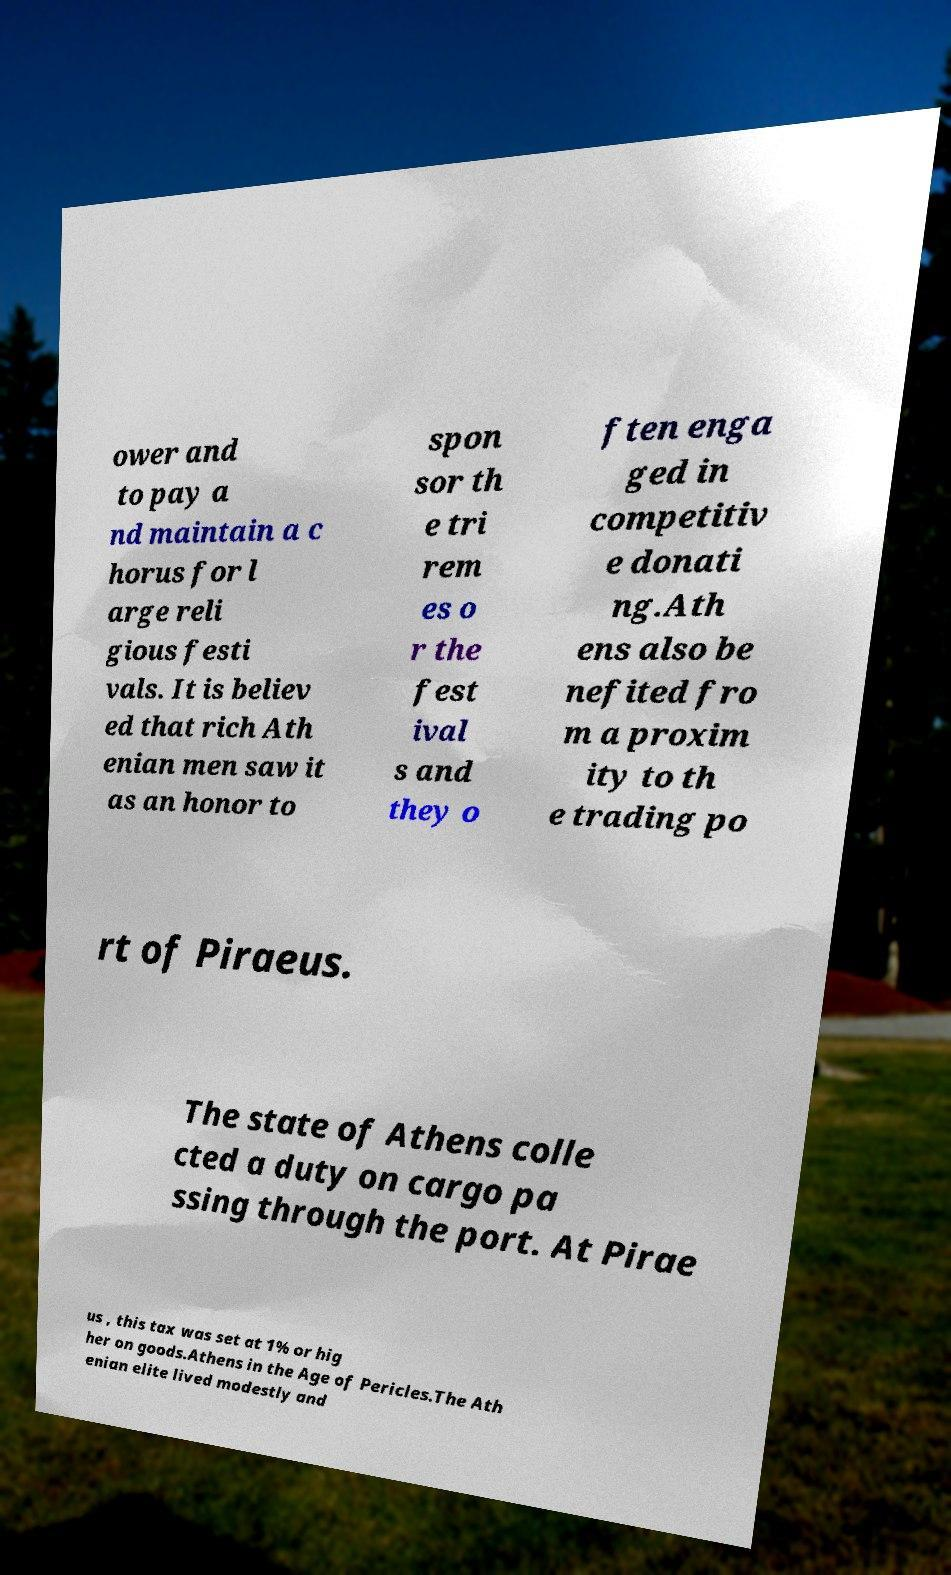Please read and relay the text visible in this image. What does it say? ower and to pay a nd maintain a c horus for l arge reli gious festi vals. It is believ ed that rich Ath enian men saw it as an honor to spon sor th e tri rem es o r the fest ival s and they o ften enga ged in competitiv e donati ng.Ath ens also be nefited fro m a proxim ity to th e trading po rt of Piraeus. The state of Athens colle cted a duty on cargo pa ssing through the port. At Pirae us , this tax was set at 1% or hig her on goods.Athens in the Age of Pericles.The Ath enian elite lived modestly and 